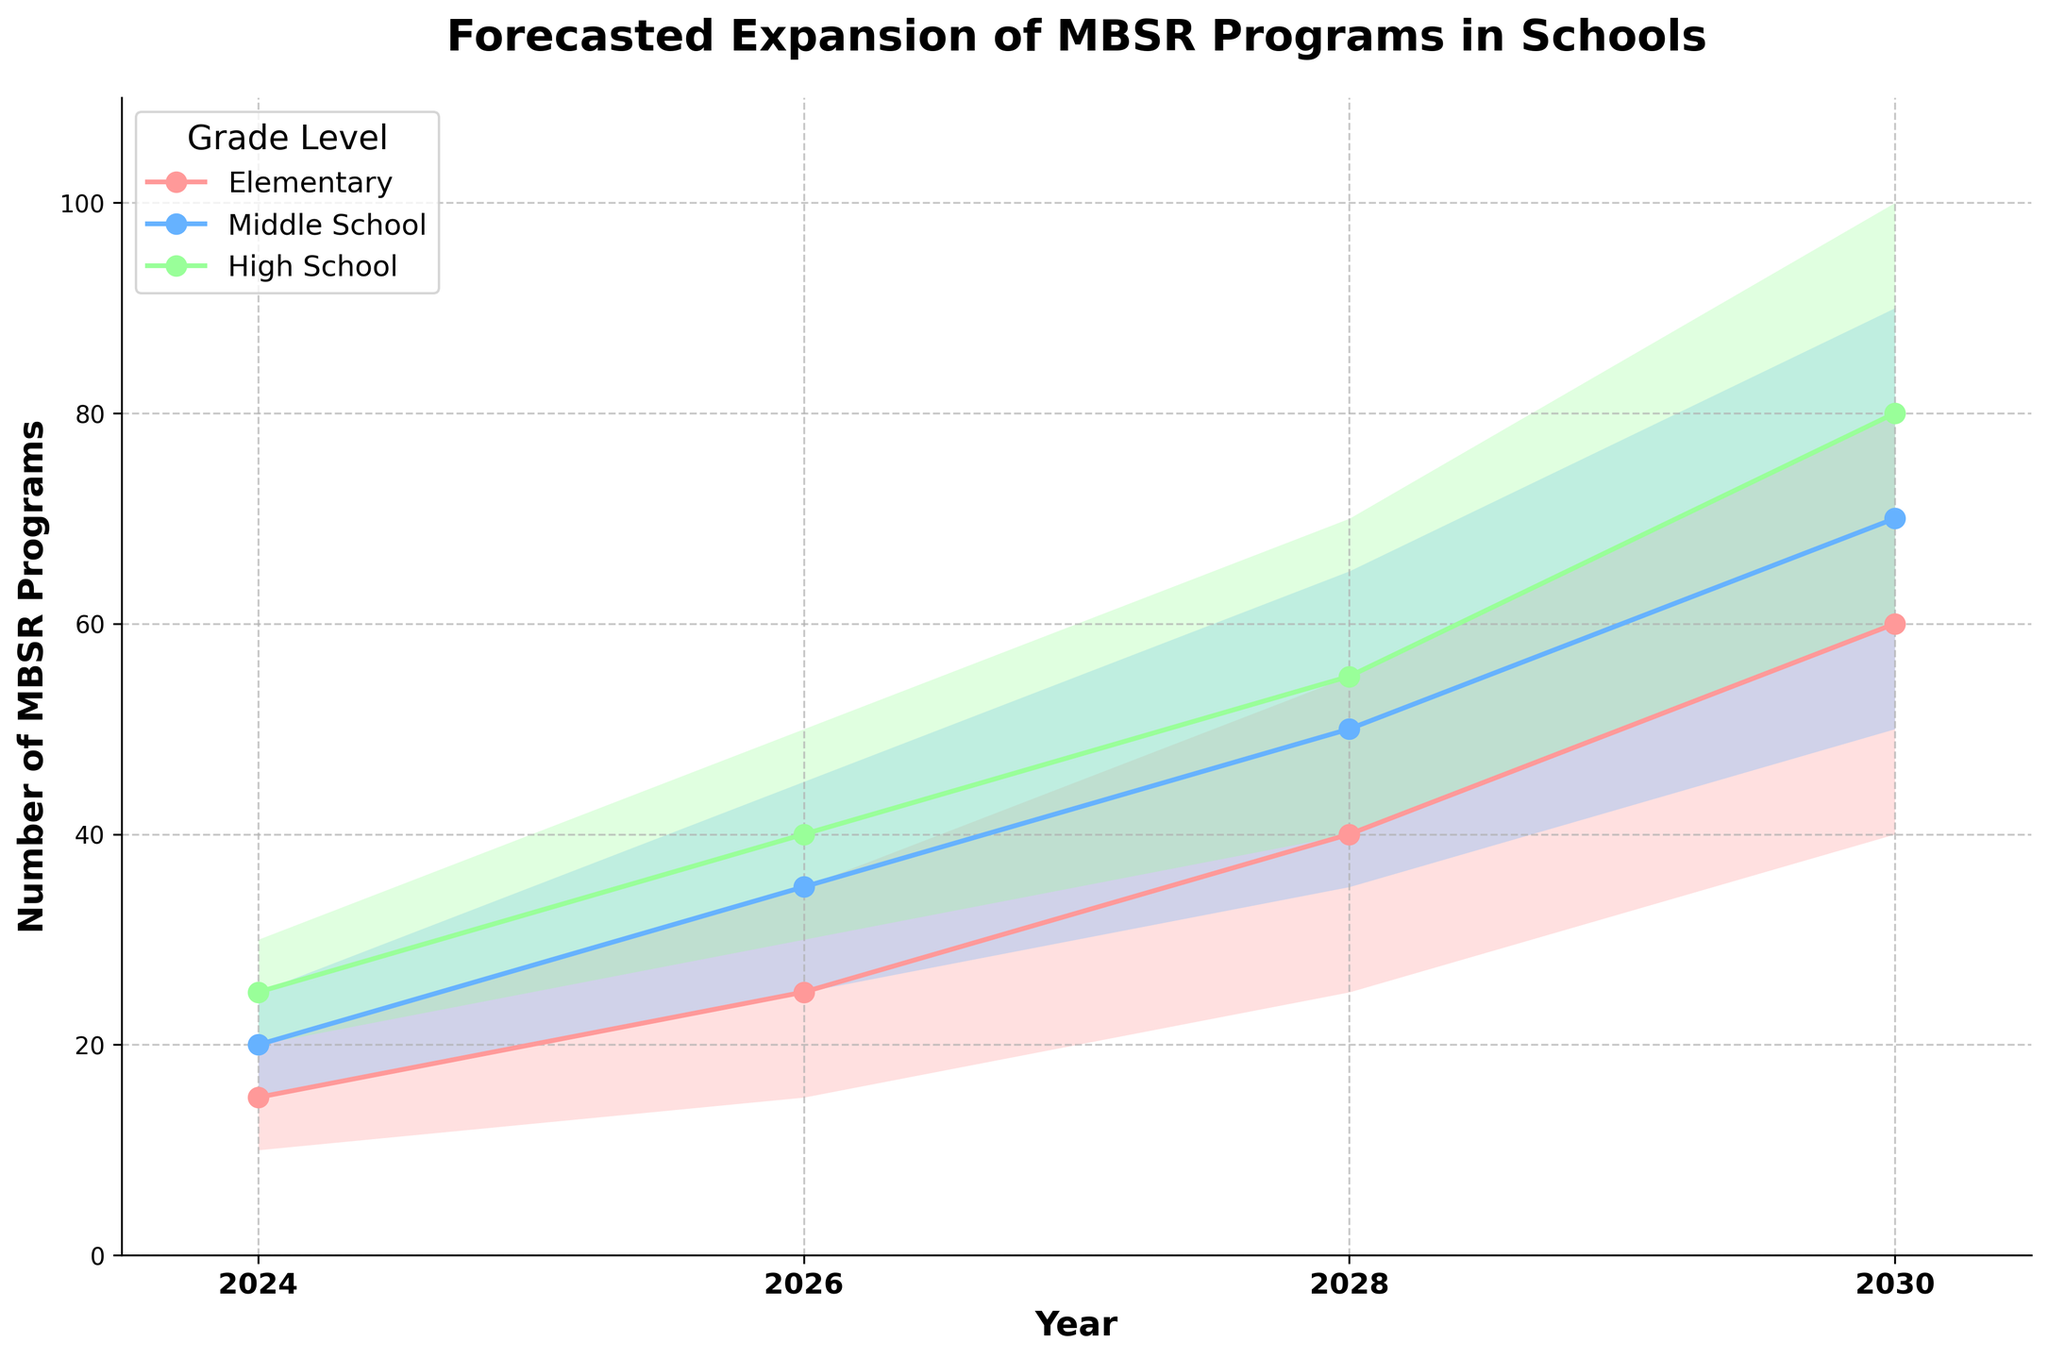What is the title of the figure? The title of the figure is usually displayed at the top of the chart. For this plot, it reads "Forecasted Expansion of MBSR Programs in Schools".
Answer: Forecasted Expansion of MBSR Programs in Schools Which grade level has the highest high estimate for MBSR programs in 2030? To determine this, locate the year 2030 and compare the high estimates across the three grade levels: Elementary, Middle School, and High School. The high estimate for High School is 100.
Answer: High School What is the medium estimate for Middle School in 2026? Locate the year 2026 and find the medium estimate for the Middle School grade level, which is listed as 35.
Answer: 35 How does the low estimate for Elementary in 2028 compare to the high estimate for Middle School in 2024? Look at the values for these respective points. The low estimate for Elementary in 2028 is 25, whereas the high estimate for Middle School in 2024 is 25. They are equal.
Answer: They are equal What is the average of the medium estimates for High School from 2024 to 2030? The medium estimates for High School are: 25 (2024), 40 (2026), 55 (2028), and 80 (2030). Their average is (25 + 40 + 55 + 80) / 4 = 50.
Answer: 50 Which year shows the largest range between the low and high estimates for Elementary grade level? Calculate the range (high - low) for Elementary in each year: 2024 (20-10=10), 2026 (35-15=20), 2028 (55-25=30), and 2030 (80-40=40). The largest range is in 2030.
Answer: 2030 By what percentage is the high estimate for Middle School in 2028 greater than the high estimate for Elementary in the same year? The high estimates for 2028 are 65 (Middle School) and 55 (Elementary). The percentage increase is ((65 - 55) / 55) * 100 = 18.18%.
Answer: 18.18% If the trends continue, what would be the expected low estimate for High School in 2032, assuming the same rate of increase between each two-year period? The increase from 2024 to 2026 is 10 (20 to 30), from 2026 to 2028 is 10 (30 to 40), and from 2028 to 2030 is 20 (40 to 60). Using the average increase of 13.33, the 2032 estimate would be around 73.33.
Answer: 73.33 